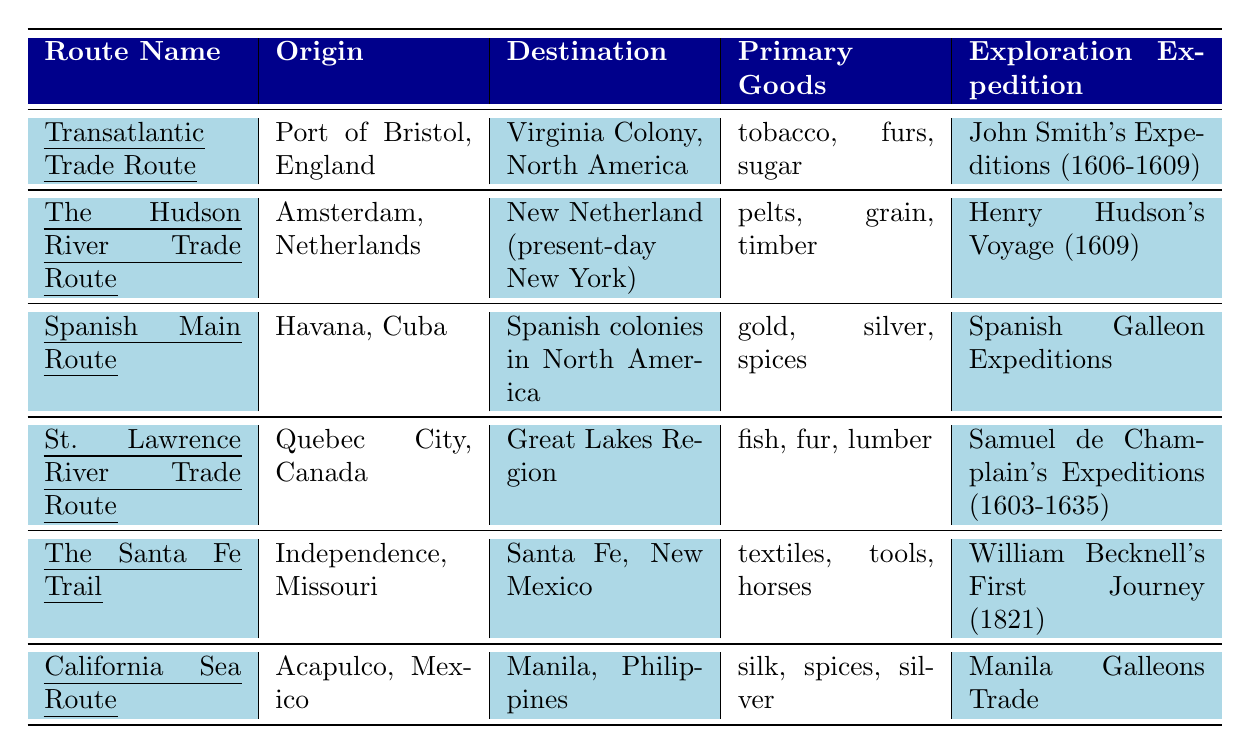What is the origin of the Transatlantic Trade Route? The table states that the origin of the Transatlantic Trade Route is the Port of Bristol, England.
Answer: Port of Bristol, England What primary goods were transported on The Hudson River Trade Route? According to the table, the primary goods transported on The Hudson River Trade Route include pelts, grain, and timber.
Answer: pelts, grain, timber Which exploration expedition was associated with the Spanish Main Route? From the table, the exploration expedition associated with the Spanish Main Route is the Spanish Galleon Expeditions.
Answer: Spanish Galleon Expeditions Which trade route had Virginia Colony as its destination? The table indicates that the trade route with Virginia Colony as its destination is the Transatlantic Trade Route.
Answer: Transatlantic Trade Route How many different primary goods are listed for the St. Lawrence River Trade Route? The table shows that three primary goods are listed for the St. Lawrence River Trade Route: fish, fur, and lumber.
Answer: 3 Is it true that the California Sea Route connects Acapulco to New York? The table states that the California Sea Route connects Acapulco to Manila, not New York; hence, the statement is false.
Answer: False Which route's exploration expedition occurred in 1821? Looking at the table, the exploration expedition that occurred in 1821 is William Becknell's First Journey, related to The Santa Fe Trail.
Answer: William Becknell's First Journey What are the different primary goods traded on the Spanish Main Route? The table lists the primary goods for the Spanish Main Route as gold, silver, and spices.
Answer: gold, silver, spices Compare the number of primary goods listed for the Transatlantic Trade Route and the St. Lawrence River Trade Route. The Transatlantic Trade Route has three primary goods (tobacco, furs, sugar), while the St. Lawrence River Trade Route also has three primary goods (fish, fur, lumber). Since both have the same number, their counts are equal.
Answer: Equal number (3 each) Which route has the earliest year of activity recorded? From the table, the earliest year of activity recorded is 1607 for the Transatlantic Trade Route. This is earlier than any other route listed.
Answer: 1607 Which route or routes involve fur as a primary good? The table shows that both the Transatlantic Trade Route and the St. Lawrence River Trade Route list fur as a primary good.
Answer: Transatlantic Trade Route and St. Lawrence River Trade Route 